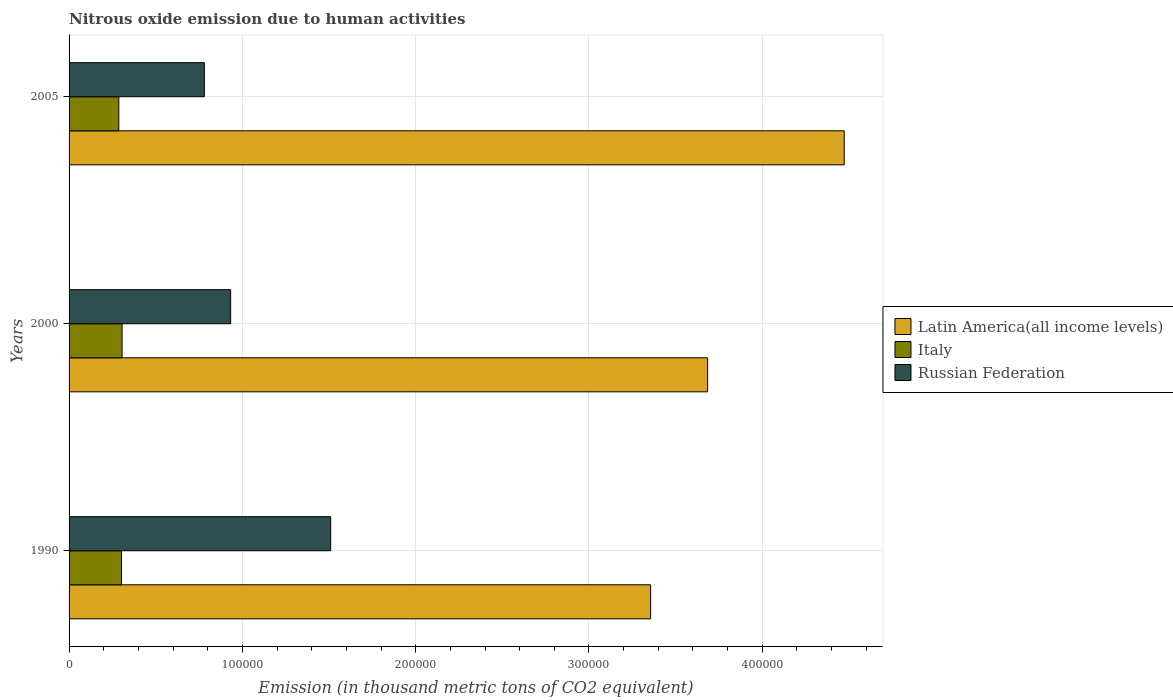How many different coloured bars are there?
Keep it short and to the point. 3. How many bars are there on the 2nd tick from the top?
Your answer should be very brief. 3. How many bars are there on the 3rd tick from the bottom?
Provide a succinct answer. 3. What is the amount of nitrous oxide emitted in Italy in 2000?
Your answer should be very brief. 3.06e+04. Across all years, what is the maximum amount of nitrous oxide emitted in Russian Federation?
Give a very brief answer. 1.51e+05. Across all years, what is the minimum amount of nitrous oxide emitted in Russian Federation?
Your answer should be compact. 7.81e+04. In which year was the amount of nitrous oxide emitted in Latin America(all income levels) maximum?
Your response must be concise. 2005. In which year was the amount of nitrous oxide emitted in Italy minimum?
Offer a very short reply. 2005. What is the total amount of nitrous oxide emitted in Latin America(all income levels) in the graph?
Your response must be concise. 1.15e+06. What is the difference between the amount of nitrous oxide emitted in Russian Federation in 1990 and that in 2005?
Provide a succinct answer. 7.29e+04. What is the difference between the amount of nitrous oxide emitted in Latin America(all income levels) in 2005 and the amount of nitrous oxide emitted in Italy in 2000?
Provide a short and direct response. 4.17e+05. What is the average amount of nitrous oxide emitted in Italy per year?
Offer a terse response. 2.99e+04. In the year 2000, what is the difference between the amount of nitrous oxide emitted in Latin America(all income levels) and amount of nitrous oxide emitted in Russian Federation?
Keep it short and to the point. 2.75e+05. What is the ratio of the amount of nitrous oxide emitted in Italy in 2000 to that in 2005?
Your response must be concise. 1.07. Is the difference between the amount of nitrous oxide emitted in Latin America(all income levels) in 1990 and 2000 greater than the difference between the amount of nitrous oxide emitted in Russian Federation in 1990 and 2000?
Your answer should be very brief. No. What is the difference between the highest and the second highest amount of nitrous oxide emitted in Russian Federation?
Give a very brief answer. 5.77e+04. What is the difference between the highest and the lowest amount of nitrous oxide emitted in Latin America(all income levels)?
Ensure brevity in your answer.  1.12e+05. Is the sum of the amount of nitrous oxide emitted in Italy in 2000 and 2005 greater than the maximum amount of nitrous oxide emitted in Russian Federation across all years?
Offer a terse response. No. What does the 1st bar from the top in 1990 represents?
Provide a short and direct response. Russian Federation. What does the 3rd bar from the bottom in 1990 represents?
Offer a very short reply. Russian Federation. Is it the case that in every year, the sum of the amount of nitrous oxide emitted in Russian Federation and amount of nitrous oxide emitted in Italy is greater than the amount of nitrous oxide emitted in Latin America(all income levels)?
Offer a terse response. No. Are all the bars in the graph horizontal?
Offer a terse response. Yes. Are the values on the major ticks of X-axis written in scientific E-notation?
Keep it short and to the point. No. Where does the legend appear in the graph?
Provide a succinct answer. Center right. How many legend labels are there?
Provide a succinct answer. 3. How are the legend labels stacked?
Provide a short and direct response. Vertical. What is the title of the graph?
Keep it short and to the point. Nitrous oxide emission due to human activities. Does "Europe(developing only)" appear as one of the legend labels in the graph?
Your response must be concise. No. What is the label or title of the X-axis?
Provide a succinct answer. Emission (in thousand metric tons of CO2 equivalent). What is the Emission (in thousand metric tons of CO2 equivalent) in Latin America(all income levels) in 1990?
Keep it short and to the point. 3.36e+05. What is the Emission (in thousand metric tons of CO2 equivalent) in Italy in 1990?
Ensure brevity in your answer.  3.03e+04. What is the Emission (in thousand metric tons of CO2 equivalent) of Russian Federation in 1990?
Ensure brevity in your answer.  1.51e+05. What is the Emission (in thousand metric tons of CO2 equivalent) of Latin America(all income levels) in 2000?
Keep it short and to the point. 3.68e+05. What is the Emission (in thousand metric tons of CO2 equivalent) of Italy in 2000?
Provide a succinct answer. 3.06e+04. What is the Emission (in thousand metric tons of CO2 equivalent) of Russian Federation in 2000?
Offer a terse response. 9.32e+04. What is the Emission (in thousand metric tons of CO2 equivalent) of Latin America(all income levels) in 2005?
Provide a short and direct response. 4.47e+05. What is the Emission (in thousand metric tons of CO2 equivalent) of Italy in 2005?
Provide a short and direct response. 2.87e+04. What is the Emission (in thousand metric tons of CO2 equivalent) in Russian Federation in 2005?
Provide a short and direct response. 7.81e+04. Across all years, what is the maximum Emission (in thousand metric tons of CO2 equivalent) in Latin America(all income levels)?
Give a very brief answer. 4.47e+05. Across all years, what is the maximum Emission (in thousand metric tons of CO2 equivalent) in Italy?
Offer a terse response. 3.06e+04. Across all years, what is the maximum Emission (in thousand metric tons of CO2 equivalent) of Russian Federation?
Ensure brevity in your answer.  1.51e+05. Across all years, what is the minimum Emission (in thousand metric tons of CO2 equivalent) of Latin America(all income levels)?
Provide a short and direct response. 3.36e+05. Across all years, what is the minimum Emission (in thousand metric tons of CO2 equivalent) in Italy?
Your answer should be compact. 2.87e+04. Across all years, what is the minimum Emission (in thousand metric tons of CO2 equivalent) in Russian Federation?
Offer a very short reply. 7.81e+04. What is the total Emission (in thousand metric tons of CO2 equivalent) in Latin America(all income levels) in the graph?
Make the answer very short. 1.15e+06. What is the total Emission (in thousand metric tons of CO2 equivalent) of Italy in the graph?
Make the answer very short. 8.96e+04. What is the total Emission (in thousand metric tons of CO2 equivalent) of Russian Federation in the graph?
Your answer should be compact. 3.22e+05. What is the difference between the Emission (in thousand metric tons of CO2 equivalent) in Latin America(all income levels) in 1990 and that in 2000?
Make the answer very short. -3.29e+04. What is the difference between the Emission (in thousand metric tons of CO2 equivalent) in Italy in 1990 and that in 2000?
Make the answer very short. -301.2. What is the difference between the Emission (in thousand metric tons of CO2 equivalent) in Russian Federation in 1990 and that in 2000?
Provide a short and direct response. 5.77e+04. What is the difference between the Emission (in thousand metric tons of CO2 equivalent) of Latin America(all income levels) in 1990 and that in 2005?
Your response must be concise. -1.12e+05. What is the difference between the Emission (in thousand metric tons of CO2 equivalent) of Italy in 1990 and that in 2005?
Provide a succinct answer. 1584.9. What is the difference between the Emission (in thousand metric tons of CO2 equivalent) of Russian Federation in 1990 and that in 2005?
Offer a very short reply. 7.29e+04. What is the difference between the Emission (in thousand metric tons of CO2 equivalent) of Latin America(all income levels) in 2000 and that in 2005?
Provide a succinct answer. -7.88e+04. What is the difference between the Emission (in thousand metric tons of CO2 equivalent) of Italy in 2000 and that in 2005?
Ensure brevity in your answer.  1886.1. What is the difference between the Emission (in thousand metric tons of CO2 equivalent) of Russian Federation in 2000 and that in 2005?
Your response must be concise. 1.52e+04. What is the difference between the Emission (in thousand metric tons of CO2 equivalent) in Latin America(all income levels) in 1990 and the Emission (in thousand metric tons of CO2 equivalent) in Italy in 2000?
Make the answer very short. 3.05e+05. What is the difference between the Emission (in thousand metric tons of CO2 equivalent) of Latin America(all income levels) in 1990 and the Emission (in thousand metric tons of CO2 equivalent) of Russian Federation in 2000?
Make the answer very short. 2.42e+05. What is the difference between the Emission (in thousand metric tons of CO2 equivalent) of Italy in 1990 and the Emission (in thousand metric tons of CO2 equivalent) of Russian Federation in 2000?
Keep it short and to the point. -6.29e+04. What is the difference between the Emission (in thousand metric tons of CO2 equivalent) of Latin America(all income levels) in 1990 and the Emission (in thousand metric tons of CO2 equivalent) of Italy in 2005?
Provide a succinct answer. 3.07e+05. What is the difference between the Emission (in thousand metric tons of CO2 equivalent) in Latin America(all income levels) in 1990 and the Emission (in thousand metric tons of CO2 equivalent) in Russian Federation in 2005?
Offer a terse response. 2.58e+05. What is the difference between the Emission (in thousand metric tons of CO2 equivalent) of Italy in 1990 and the Emission (in thousand metric tons of CO2 equivalent) of Russian Federation in 2005?
Provide a short and direct response. -4.78e+04. What is the difference between the Emission (in thousand metric tons of CO2 equivalent) in Latin America(all income levels) in 2000 and the Emission (in thousand metric tons of CO2 equivalent) in Italy in 2005?
Ensure brevity in your answer.  3.40e+05. What is the difference between the Emission (in thousand metric tons of CO2 equivalent) of Latin America(all income levels) in 2000 and the Emission (in thousand metric tons of CO2 equivalent) of Russian Federation in 2005?
Provide a short and direct response. 2.90e+05. What is the difference between the Emission (in thousand metric tons of CO2 equivalent) in Italy in 2000 and the Emission (in thousand metric tons of CO2 equivalent) in Russian Federation in 2005?
Your answer should be compact. -4.75e+04. What is the average Emission (in thousand metric tons of CO2 equivalent) in Latin America(all income levels) per year?
Ensure brevity in your answer.  3.84e+05. What is the average Emission (in thousand metric tons of CO2 equivalent) of Italy per year?
Offer a terse response. 2.99e+04. What is the average Emission (in thousand metric tons of CO2 equivalent) of Russian Federation per year?
Offer a very short reply. 1.07e+05. In the year 1990, what is the difference between the Emission (in thousand metric tons of CO2 equivalent) in Latin America(all income levels) and Emission (in thousand metric tons of CO2 equivalent) in Italy?
Your answer should be compact. 3.05e+05. In the year 1990, what is the difference between the Emission (in thousand metric tons of CO2 equivalent) in Latin America(all income levels) and Emission (in thousand metric tons of CO2 equivalent) in Russian Federation?
Your response must be concise. 1.85e+05. In the year 1990, what is the difference between the Emission (in thousand metric tons of CO2 equivalent) in Italy and Emission (in thousand metric tons of CO2 equivalent) in Russian Federation?
Keep it short and to the point. -1.21e+05. In the year 2000, what is the difference between the Emission (in thousand metric tons of CO2 equivalent) in Latin America(all income levels) and Emission (in thousand metric tons of CO2 equivalent) in Italy?
Your answer should be compact. 3.38e+05. In the year 2000, what is the difference between the Emission (in thousand metric tons of CO2 equivalent) of Latin America(all income levels) and Emission (in thousand metric tons of CO2 equivalent) of Russian Federation?
Offer a very short reply. 2.75e+05. In the year 2000, what is the difference between the Emission (in thousand metric tons of CO2 equivalent) of Italy and Emission (in thousand metric tons of CO2 equivalent) of Russian Federation?
Give a very brief answer. -6.26e+04. In the year 2005, what is the difference between the Emission (in thousand metric tons of CO2 equivalent) of Latin America(all income levels) and Emission (in thousand metric tons of CO2 equivalent) of Italy?
Provide a short and direct response. 4.19e+05. In the year 2005, what is the difference between the Emission (in thousand metric tons of CO2 equivalent) in Latin America(all income levels) and Emission (in thousand metric tons of CO2 equivalent) in Russian Federation?
Give a very brief answer. 3.69e+05. In the year 2005, what is the difference between the Emission (in thousand metric tons of CO2 equivalent) of Italy and Emission (in thousand metric tons of CO2 equivalent) of Russian Federation?
Your response must be concise. -4.94e+04. What is the ratio of the Emission (in thousand metric tons of CO2 equivalent) in Latin America(all income levels) in 1990 to that in 2000?
Provide a succinct answer. 0.91. What is the ratio of the Emission (in thousand metric tons of CO2 equivalent) of Italy in 1990 to that in 2000?
Provide a succinct answer. 0.99. What is the ratio of the Emission (in thousand metric tons of CO2 equivalent) in Russian Federation in 1990 to that in 2000?
Your answer should be compact. 1.62. What is the ratio of the Emission (in thousand metric tons of CO2 equivalent) of Latin America(all income levels) in 1990 to that in 2005?
Provide a short and direct response. 0.75. What is the ratio of the Emission (in thousand metric tons of CO2 equivalent) in Italy in 1990 to that in 2005?
Give a very brief answer. 1.06. What is the ratio of the Emission (in thousand metric tons of CO2 equivalent) in Russian Federation in 1990 to that in 2005?
Give a very brief answer. 1.93. What is the ratio of the Emission (in thousand metric tons of CO2 equivalent) of Latin America(all income levels) in 2000 to that in 2005?
Your answer should be very brief. 0.82. What is the ratio of the Emission (in thousand metric tons of CO2 equivalent) of Italy in 2000 to that in 2005?
Keep it short and to the point. 1.07. What is the ratio of the Emission (in thousand metric tons of CO2 equivalent) of Russian Federation in 2000 to that in 2005?
Give a very brief answer. 1.19. What is the difference between the highest and the second highest Emission (in thousand metric tons of CO2 equivalent) in Latin America(all income levels)?
Keep it short and to the point. 7.88e+04. What is the difference between the highest and the second highest Emission (in thousand metric tons of CO2 equivalent) in Italy?
Give a very brief answer. 301.2. What is the difference between the highest and the second highest Emission (in thousand metric tons of CO2 equivalent) of Russian Federation?
Offer a terse response. 5.77e+04. What is the difference between the highest and the lowest Emission (in thousand metric tons of CO2 equivalent) in Latin America(all income levels)?
Your answer should be very brief. 1.12e+05. What is the difference between the highest and the lowest Emission (in thousand metric tons of CO2 equivalent) of Italy?
Make the answer very short. 1886.1. What is the difference between the highest and the lowest Emission (in thousand metric tons of CO2 equivalent) in Russian Federation?
Provide a succinct answer. 7.29e+04. 